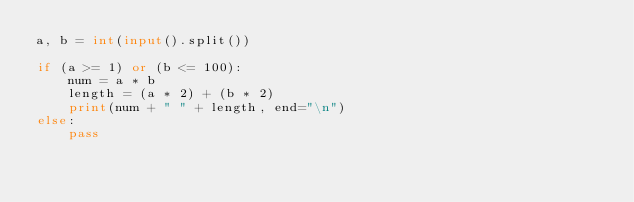<code> <loc_0><loc_0><loc_500><loc_500><_Python_>a, b = int(input().split())

if (a >= 1) or (b <= 100):
    num = a * b
    length = (a * 2) + (b * 2)
    print(num + " " + length, end="\n")
else:
    pass</code> 